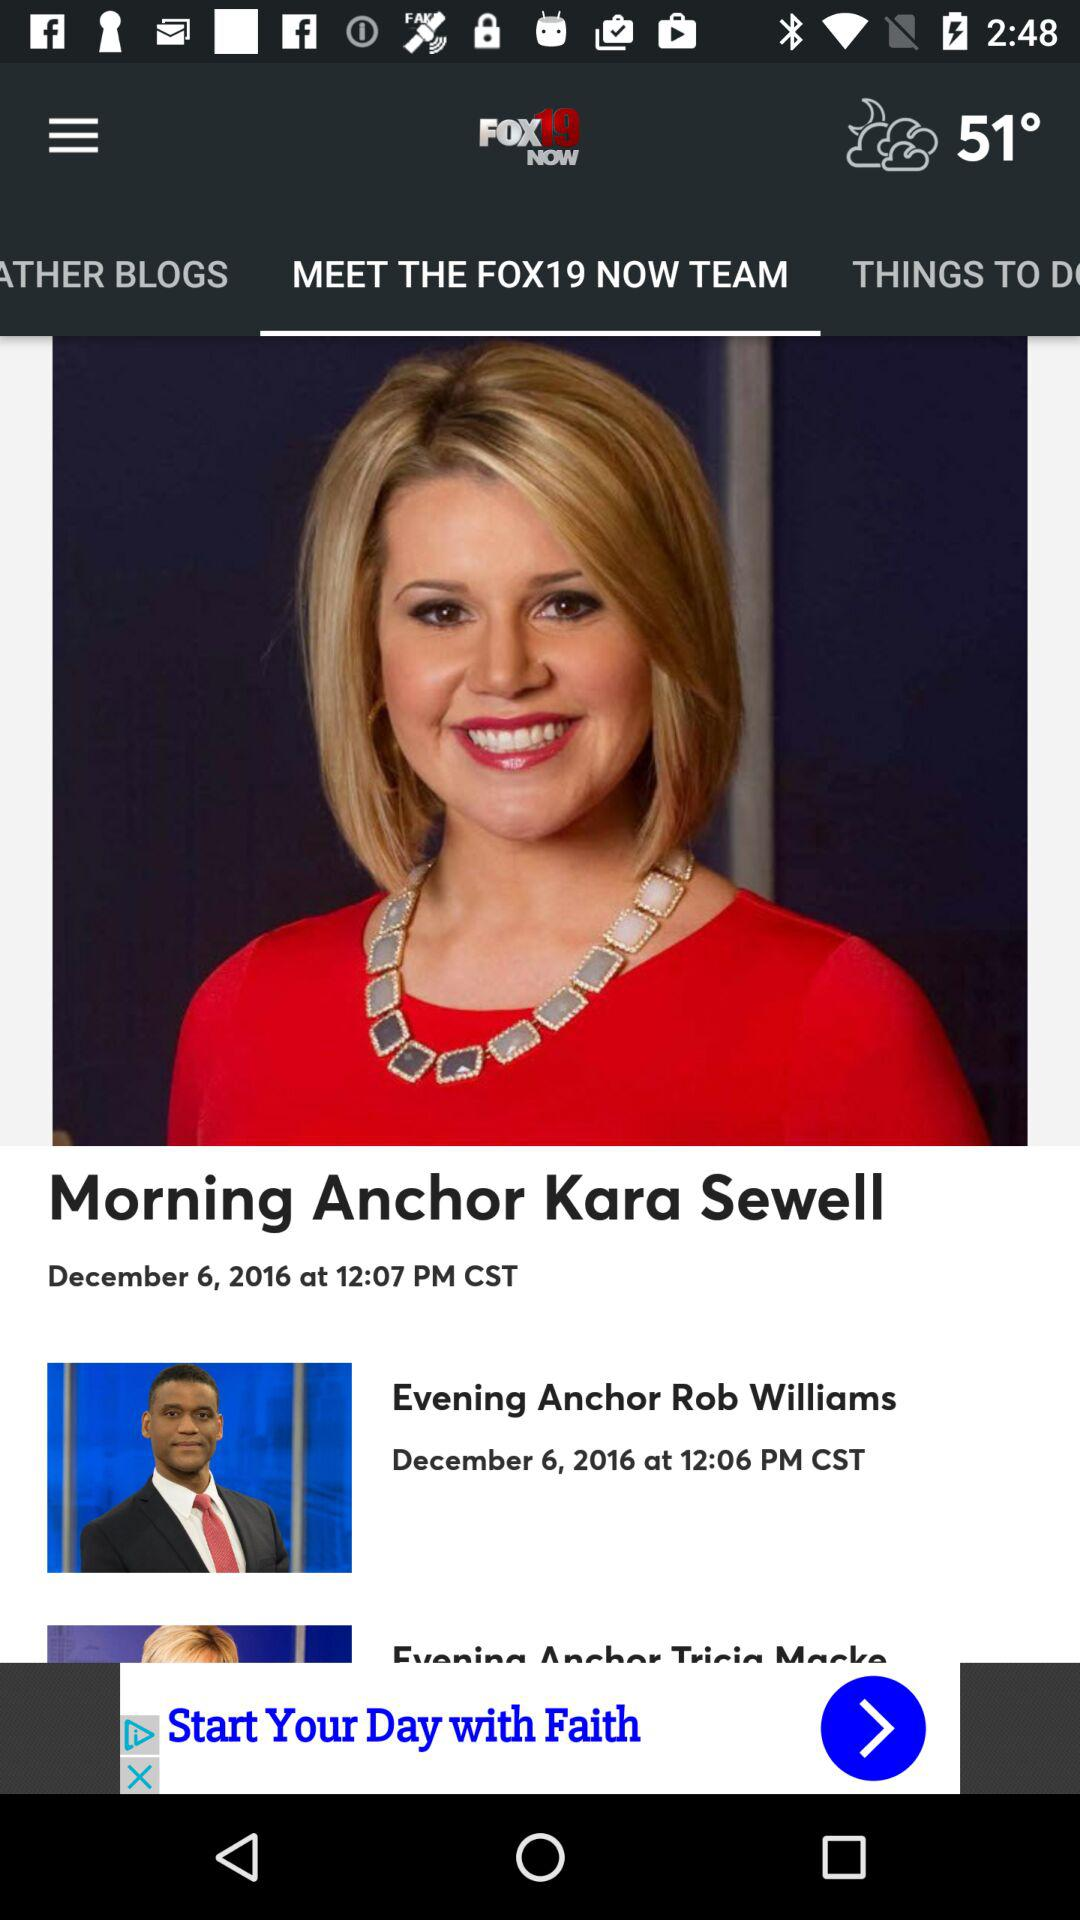What is the temperature? The temperature is 51°. 